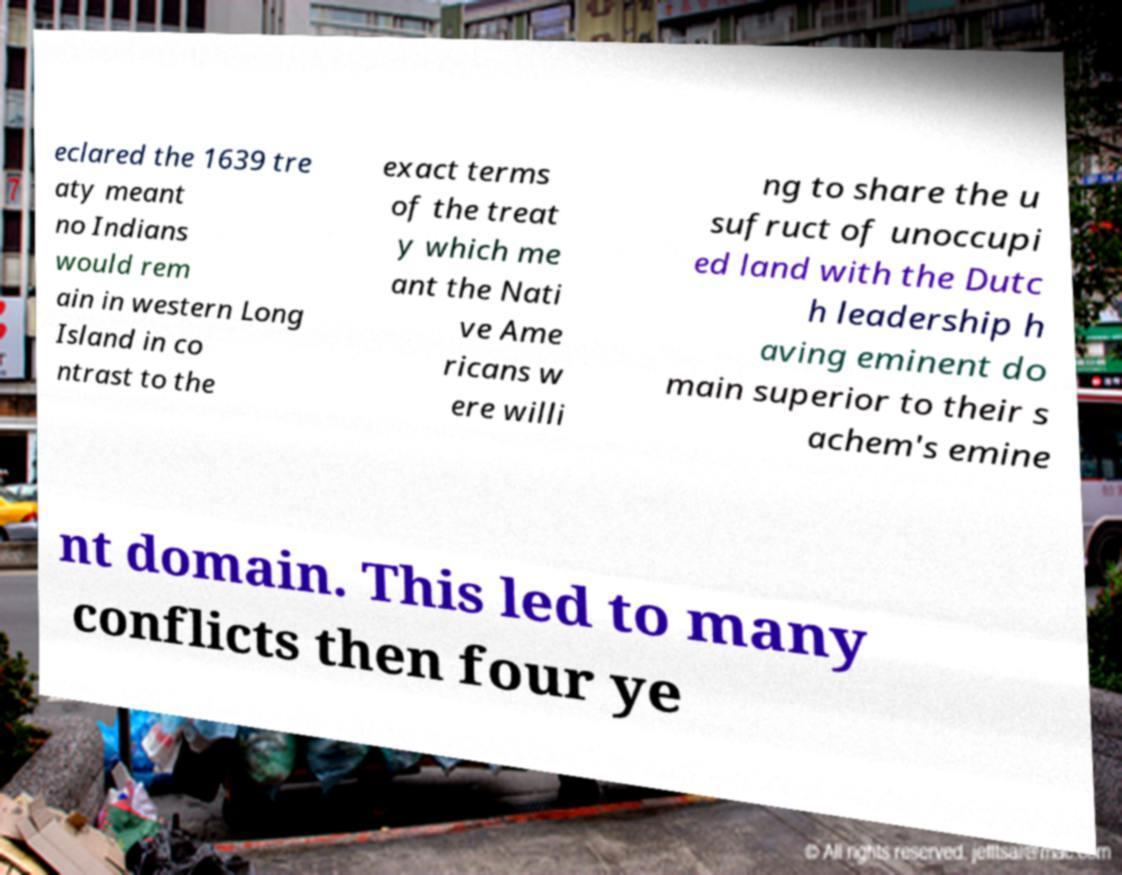What messages or text are displayed in this image? I need them in a readable, typed format. eclared the 1639 tre aty meant no Indians would rem ain in western Long Island in co ntrast to the exact terms of the treat y which me ant the Nati ve Ame ricans w ere willi ng to share the u sufruct of unoccupi ed land with the Dutc h leadership h aving eminent do main superior to their s achem's emine nt domain. This led to many conflicts then four ye 